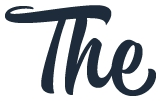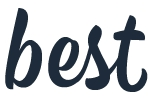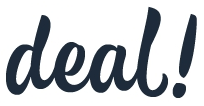Read the text from these images in sequence, separated by a semicolon. The; best; deal! 